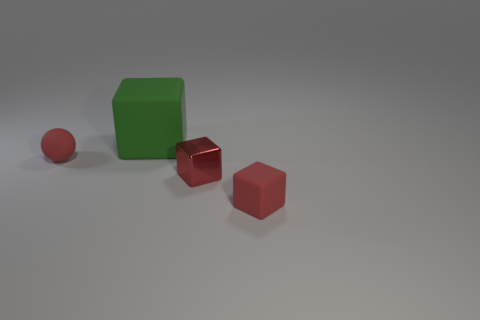Add 1 small red rubber things. How many objects exist? 5 Subtract all tiny red blocks. How many blocks are left? 1 Subtract all green blocks. How many blocks are left? 2 Subtract all cubes. How many objects are left? 1 Subtract all brown cubes. Subtract all blue cylinders. How many cubes are left? 3 Subtract all purple cubes. How many yellow spheres are left? 0 Subtract all small red matte cubes. Subtract all red matte blocks. How many objects are left? 2 Add 1 balls. How many balls are left? 2 Add 2 balls. How many balls exist? 3 Subtract 0 red cylinders. How many objects are left? 4 